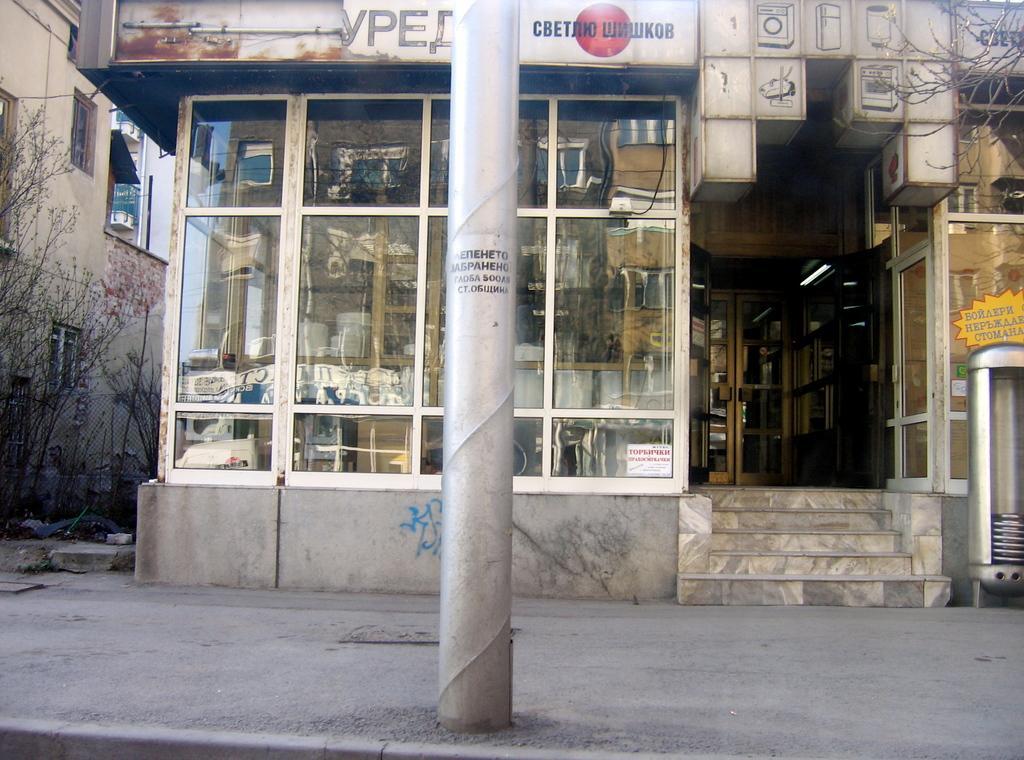Could you give a brief overview of what you see in this image? In the foreground of this image, there is a pole on the side path. We can also see few trees and a building on the left and there are few objects in the glass of a building and also an object on the right. 